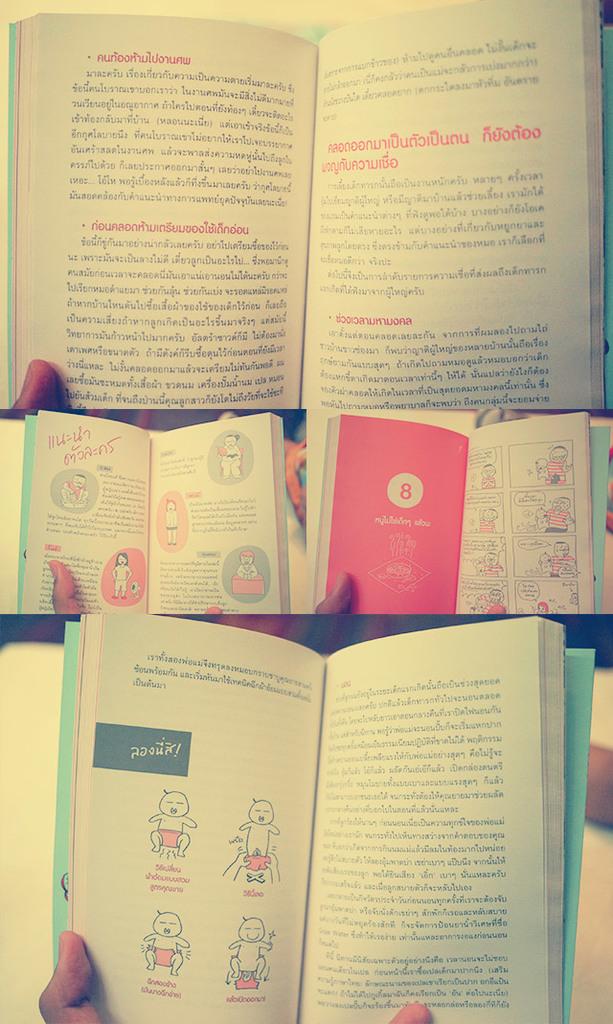What chapter are they reading?
Your answer should be very brief. 8. 